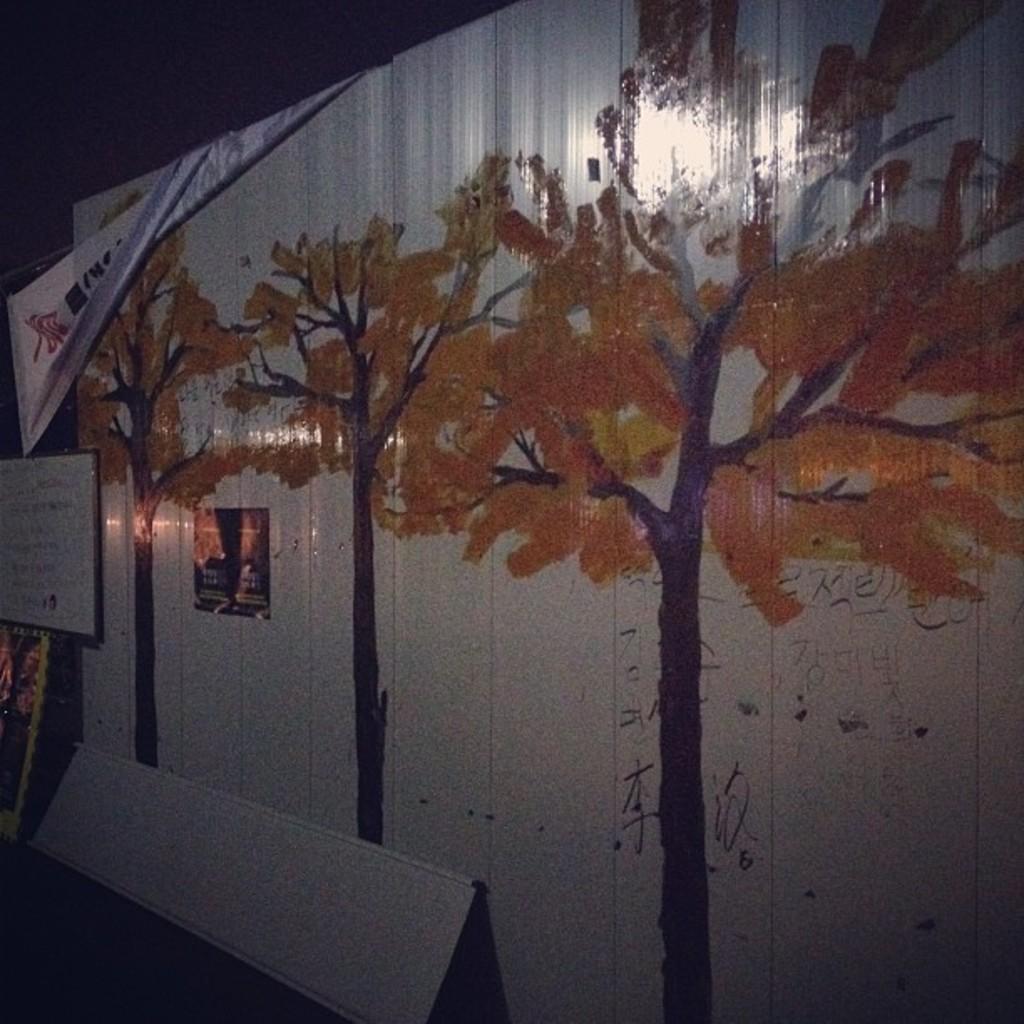Can you describe this image briefly? In this image we can see a painting of few trees on the wall, there we can see a small stand behind the wall. 